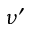<formula> <loc_0><loc_0><loc_500><loc_500>\nu ^ { \prime }</formula> 